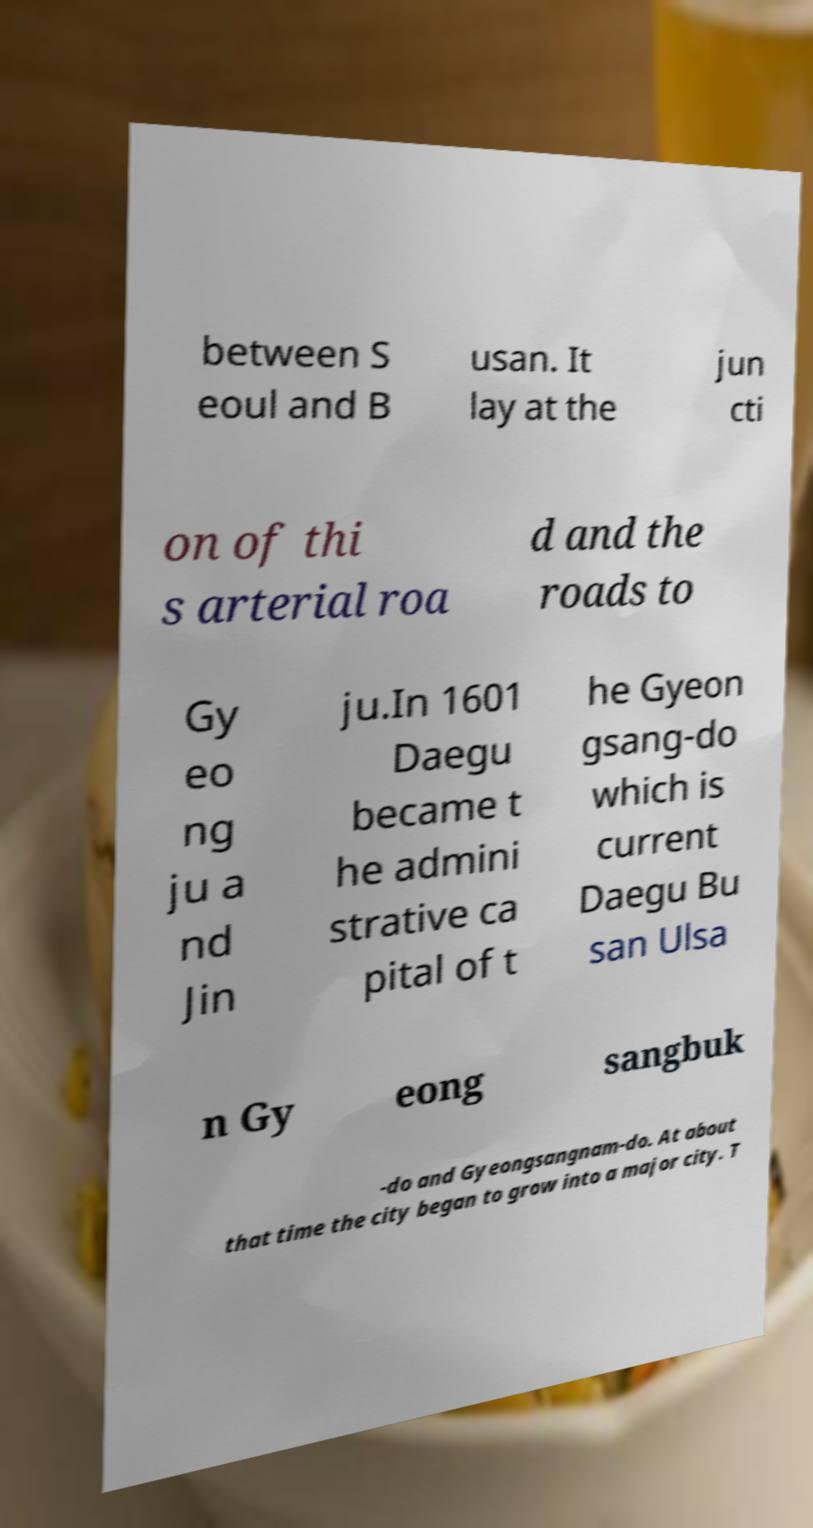Please read and relay the text visible in this image. What does it say? between S eoul and B usan. It lay at the jun cti on of thi s arterial roa d and the roads to Gy eo ng ju a nd Jin ju.In 1601 Daegu became t he admini strative ca pital of t he Gyeon gsang-do which is current Daegu Bu san Ulsa n Gy eong sangbuk -do and Gyeongsangnam-do. At about that time the city began to grow into a major city. T 